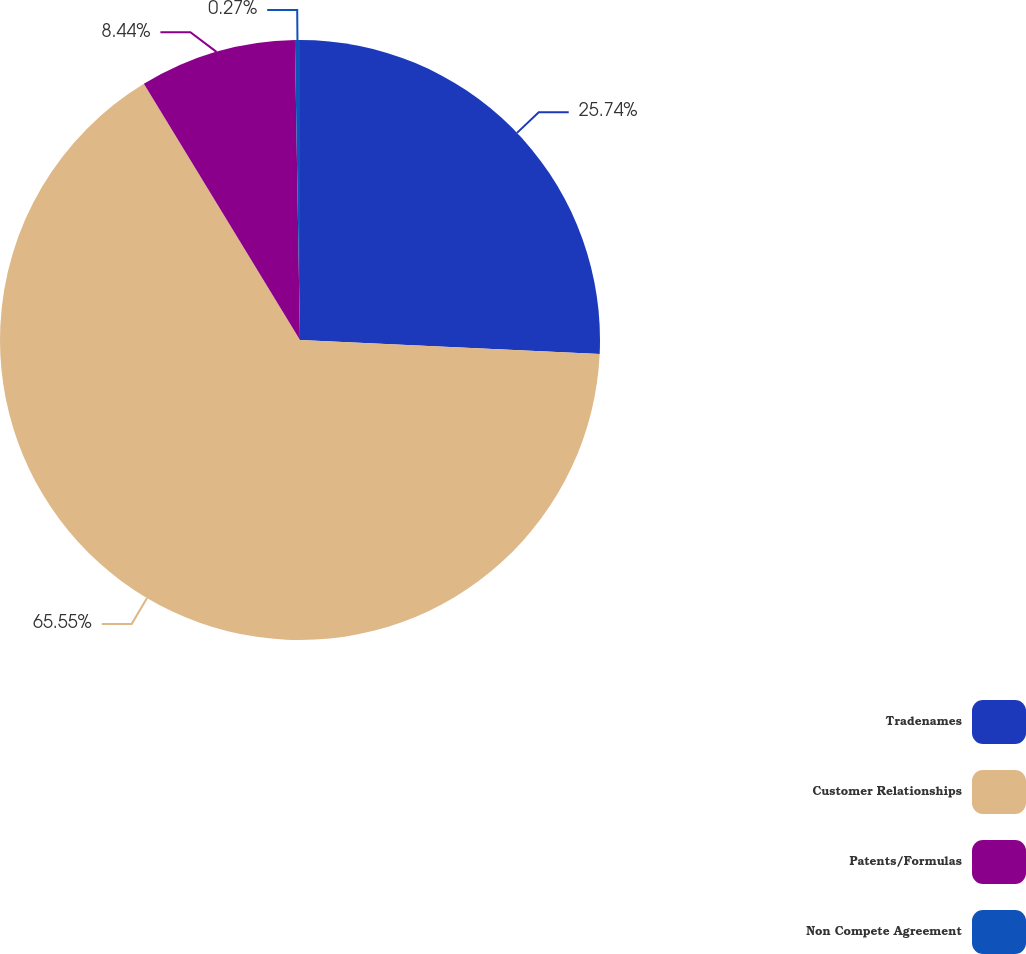<chart> <loc_0><loc_0><loc_500><loc_500><pie_chart><fcel>Tradenames<fcel>Customer Relationships<fcel>Patents/Formulas<fcel>Non Compete Agreement<nl><fcel>25.74%<fcel>65.54%<fcel>8.44%<fcel>0.27%<nl></chart> 